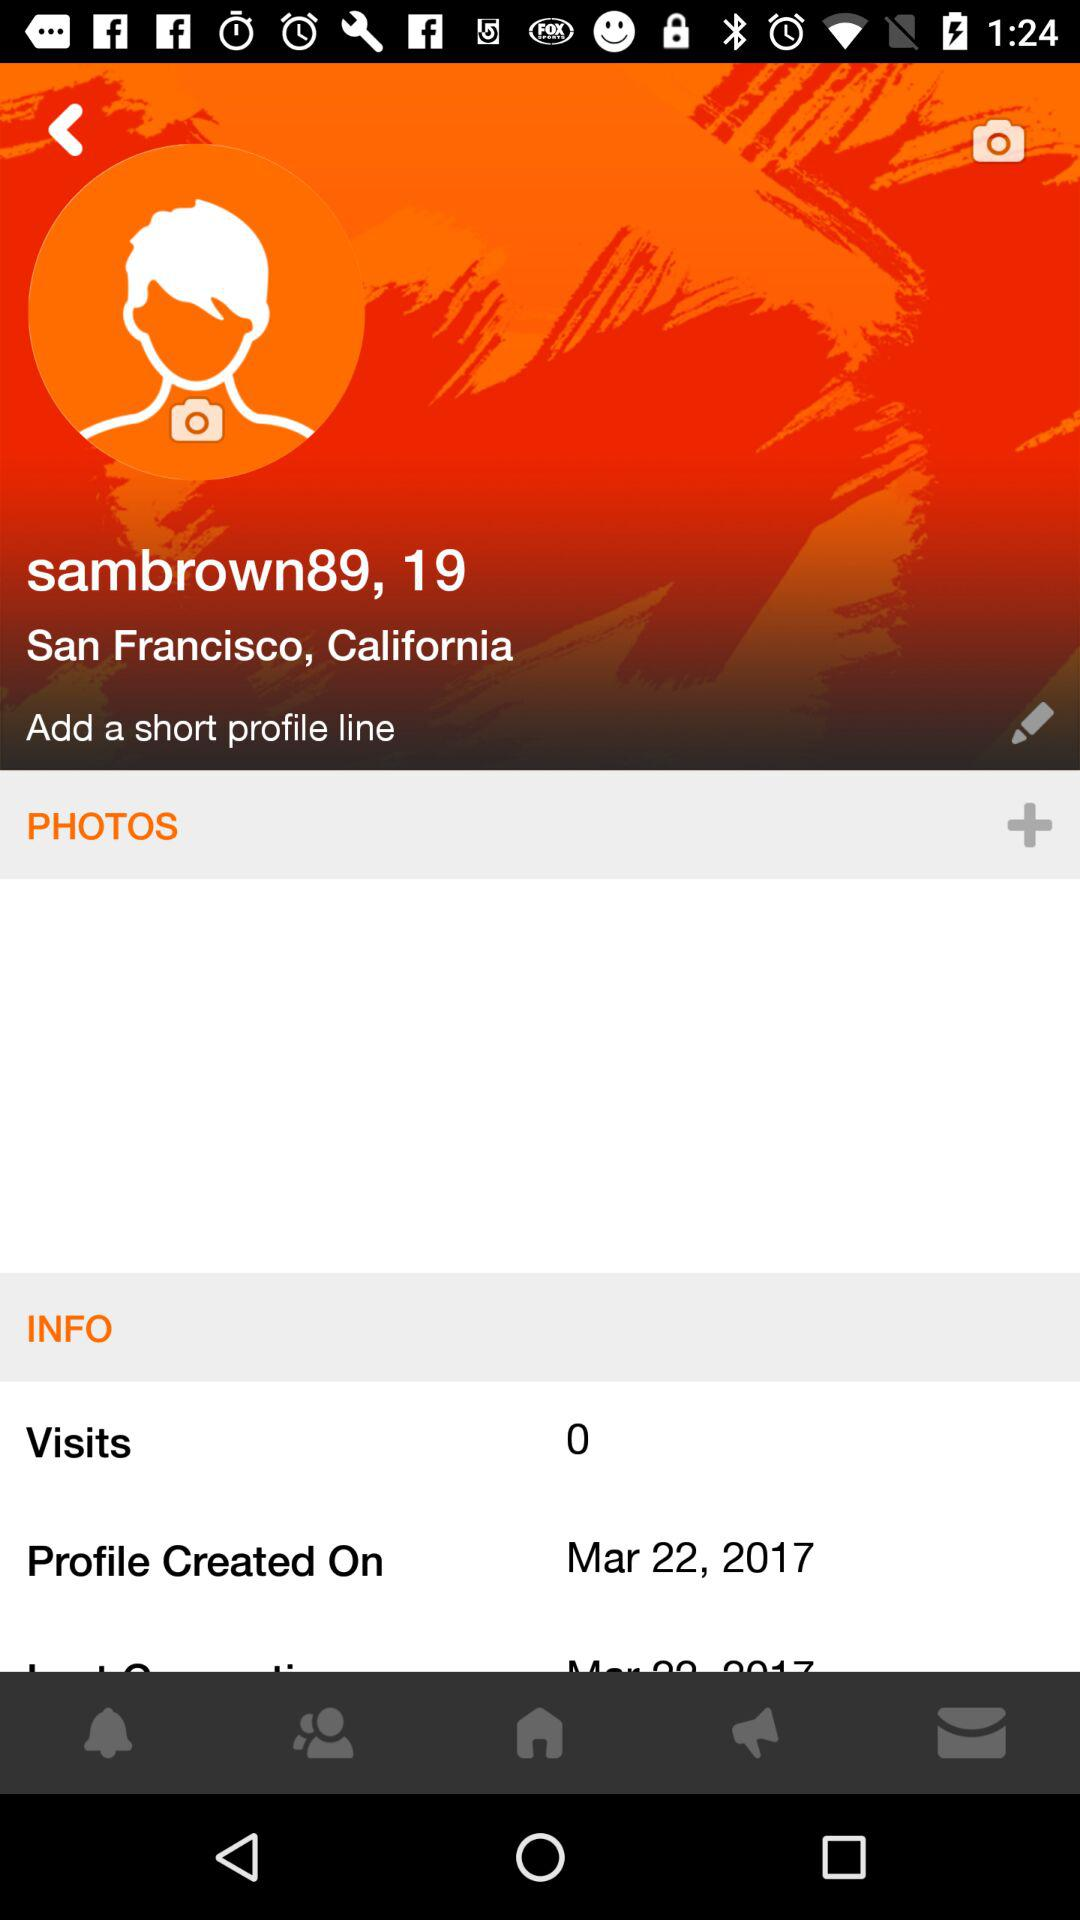Where did the user live? The user lives in "San Francisco, California". 